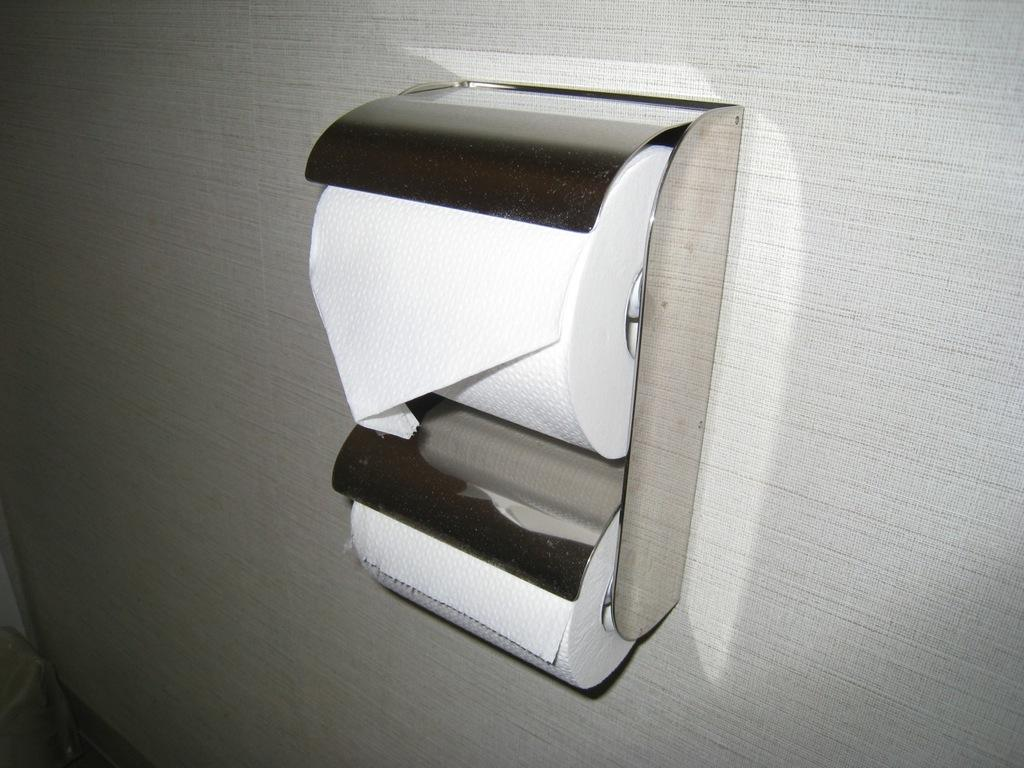What type of item is visible in the image? There are tissue papers in the image. Where are the tissue papers located? The tissue papers are present on a surface. What type of sport is being played with the tissue papers in the image? There is no sport being played in the image, as it only features tissue papers on a surface. What type of creature is present in the image, resembling a ray? There is no creature resembling a ray present in the image; it only features tissue papers on a surface. 